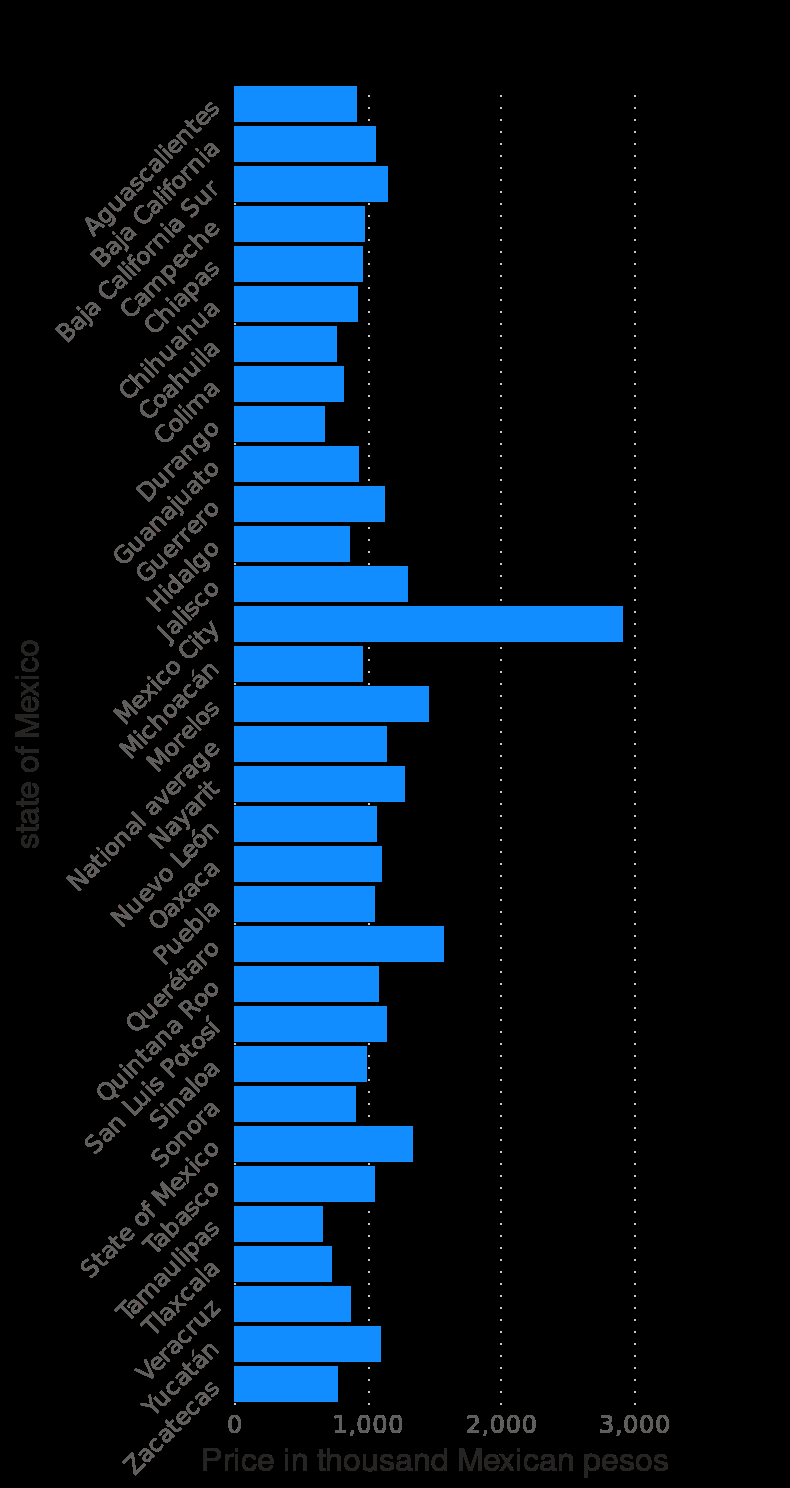<image>
please summary the statistics and relations of the chart Mexico City has the most expensive average housing price in Mexico in the 2nd quarter of 2020. Durango and Tamaulipas are almost tied at being the cities with the cheapest average housing prices. The average Mexico City housing price is almost double of its successor, Queretaro. 